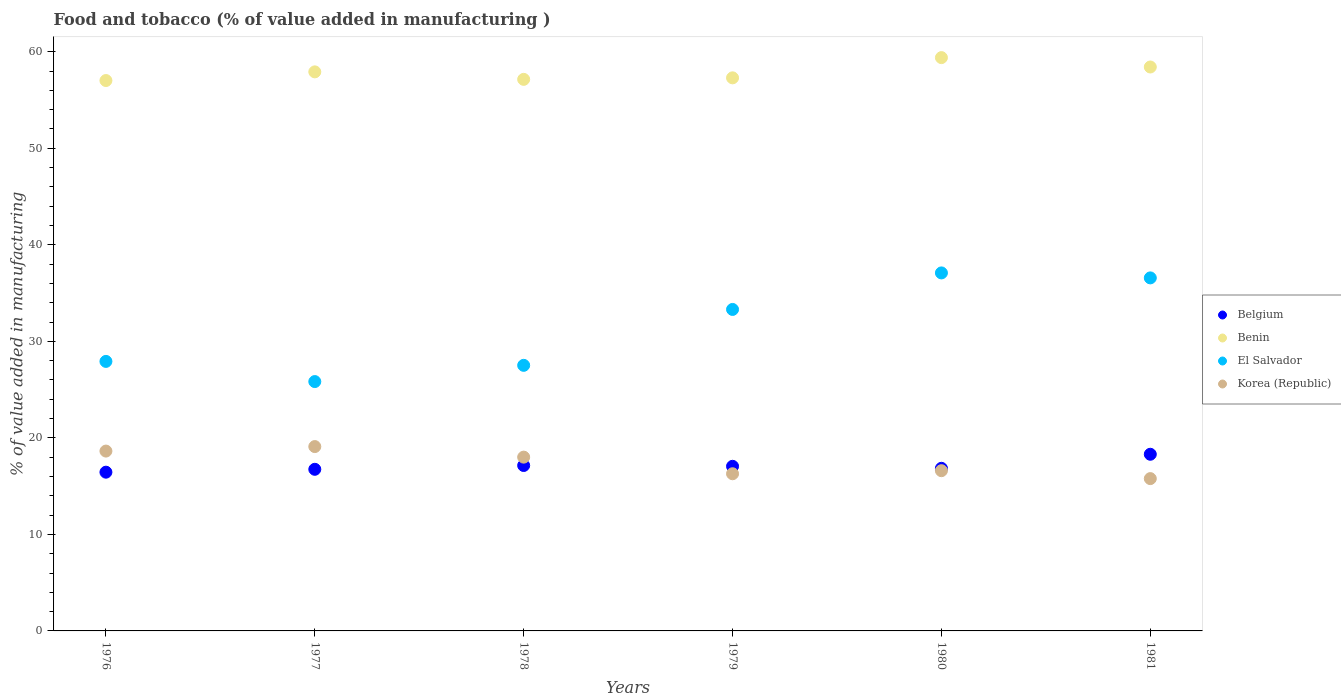How many different coloured dotlines are there?
Ensure brevity in your answer.  4. What is the value added in manufacturing food and tobacco in Belgium in 1976?
Keep it short and to the point. 16.44. Across all years, what is the maximum value added in manufacturing food and tobacco in El Salvador?
Provide a succinct answer. 37.09. Across all years, what is the minimum value added in manufacturing food and tobacco in Belgium?
Offer a terse response. 16.44. In which year was the value added in manufacturing food and tobacco in Benin minimum?
Give a very brief answer. 1976. What is the total value added in manufacturing food and tobacco in Belgium in the graph?
Offer a terse response. 102.52. What is the difference between the value added in manufacturing food and tobacco in Belgium in 1978 and that in 1979?
Your answer should be very brief. 0.08. What is the difference between the value added in manufacturing food and tobacco in Benin in 1981 and the value added in manufacturing food and tobacco in Belgium in 1978?
Ensure brevity in your answer.  41.28. What is the average value added in manufacturing food and tobacco in Benin per year?
Your answer should be very brief. 57.86. In the year 1979, what is the difference between the value added in manufacturing food and tobacco in Benin and value added in manufacturing food and tobacco in El Salvador?
Offer a terse response. 23.99. In how many years, is the value added in manufacturing food and tobacco in El Salvador greater than 14 %?
Offer a terse response. 6. What is the ratio of the value added in manufacturing food and tobacco in El Salvador in 1976 to that in 1979?
Make the answer very short. 0.84. Is the value added in manufacturing food and tobacco in Benin in 1977 less than that in 1981?
Offer a terse response. Yes. What is the difference between the highest and the second highest value added in manufacturing food and tobacco in Korea (Republic)?
Provide a short and direct response. 0.47. What is the difference between the highest and the lowest value added in manufacturing food and tobacco in Korea (Republic)?
Offer a very short reply. 3.32. In how many years, is the value added in manufacturing food and tobacco in Benin greater than the average value added in manufacturing food and tobacco in Benin taken over all years?
Make the answer very short. 3. Is the sum of the value added in manufacturing food and tobacco in Belgium in 1976 and 1977 greater than the maximum value added in manufacturing food and tobacco in Benin across all years?
Provide a short and direct response. No. Is it the case that in every year, the sum of the value added in manufacturing food and tobacco in Korea (Republic) and value added in manufacturing food and tobacco in Belgium  is greater than the value added in manufacturing food and tobacco in El Salvador?
Ensure brevity in your answer.  No. How many dotlines are there?
Offer a very short reply. 4. What is the difference between two consecutive major ticks on the Y-axis?
Your response must be concise. 10. Where does the legend appear in the graph?
Give a very brief answer. Center right. How are the legend labels stacked?
Keep it short and to the point. Vertical. What is the title of the graph?
Ensure brevity in your answer.  Food and tobacco (% of value added in manufacturing ). Does "Mexico" appear as one of the legend labels in the graph?
Offer a terse response. No. What is the label or title of the X-axis?
Your response must be concise. Years. What is the label or title of the Y-axis?
Offer a very short reply. % of value added in manufacturing. What is the % of value added in manufacturing of Belgium in 1976?
Your answer should be compact. 16.44. What is the % of value added in manufacturing in Benin in 1976?
Keep it short and to the point. 57.02. What is the % of value added in manufacturing of El Salvador in 1976?
Provide a succinct answer. 27.92. What is the % of value added in manufacturing in Korea (Republic) in 1976?
Provide a short and direct response. 18.63. What is the % of value added in manufacturing of Belgium in 1977?
Make the answer very short. 16.74. What is the % of value added in manufacturing of Benin in 1977?
Keep it short and to the point. 57.91. What is the % of value added in manufacturing of El Salvador in 1977?
Make the answer very short. 25.83. What is the % of value added in manufacturing in Korea (Republic) in 1977?
Offer a terse response. 19.1. What is the % of value added in manufacturing in Belgium in 1978?
Your response must be concise. 17.14. What is the % of value added in manufacturing of Benin in 1978?
Your response must be concise. 57.14. What is the % of value added in manufacturing in El Salvador in 1978?
Keep it short and to the point. 27.51. What is the % of value added in manufacturing of Korea (Republic) in 1978?
Your answer should be very brief. 18. What is the % of value added in manufacturing in Belgium in 1979?
Your response must be concise. 17.05. What is the % of value added in manufacturing of Benin in 1979?
Provide a succinct answer. 57.29. What is the % of value added in manufacturing in El Salvador in 1979?
Make the answer very short. 33.3. What is the % of value added in manufacturing in Korea (Republic) in 1979?
Offer a very short reply. 16.28. What is the % of value added in manufacturing in Belgium in 1980?
Offer a terse response. 16.85. What is the % of value added in manufacturing of Benin in 1980?
Give a very brief answer. 59.39. What is the % of value added in manufacturing of El Salvador in 1980?
Offer a very short reply. 37.09. What is the % of value added in manufacturing of Korea (Republic) in 1980?
Provide a succinct answer. 16.6. What is the % of value added in manufacturing in Belgium in 1981?
Offer a terse response. 18.3. What is the % of value added in manufacturing of Benin in 1981?
Offer a terse response. 58.42. What is the % of value added in manufacturing of El Salvador in 1981?
Offer a very short reply. 36.57. What is the % of value added in manufacturing of Korea (Republic) in 1981?
Provide a succinct answer. 15.78. Across all years, what is the maximum % of value added in manufacturing in Belgium?
Your answer should be very brief. 18.3. Across all years, what is the maximum % of value added in manufacturing of Benin?
Provide a succinct answer. 59.39. Across all years, what is the maximum % of value added in manufacturing of El Salvador?
Offer a very short reply. 37.09. Across all years, what is the maximum % of value added in manufacturing of Korea (Republic)?
Make the answer very short. 19.1. Across all years, what is the minimum % of value added in manufacturing of Belgium?
Give a very brief answer. 16.44. Across all years, what is the minimum % of value added in manufacturing of Benin?
Provide a short and direct response. 57.02. Across all years, what is the minimum % of value added in manufacturing in El Salvador?
Provide a short and direct response. 25.83. Across all years, what is the minimum % of value added in manufacturing of Korea (Republic)?
Your answer should be very brief. 15.78. What is the total % of value added in manufacturing in Belgium in the graph?
Make the answer very short. 102.52. What is the total % of value added in manufacturing of Benin in the graph?
Provide a succinct answer. 347.17. What is the total % of value added in manufacturing in El Salvador in the graph?
Keep it short and to the point. 188.22. What is the total % of value added in manufacturing in Korea (Republic) in the graph?
Your response must be concise. 104.39. What is the difference between the % of value added in manufacturing of Belgium in 1976 and that in 1977?
Make the answer very short. -0.3. What is the difference between the % of value added in manufacturing of Benin in 1976 and that in 1977?
Give a very brief answer. -0.9. What is the difference between the % of value added in manufacturing in El Salvador in 1976 and that in 1977?
Keep it short and to the point. 2.09. What is the difference between the % of value added in manufacturing in Korea (Republic) in 1976 and that in 1977?
Make the answer very short. -0.47. What is the difference between the % of value added in manufacturing of Belgium in 1976 and that in 1978?
Your answer should be compact. -0.69. What is the difference between the % of value added in manufacturing in Benin in 1976 and that in 1978?
Make the answer very short. -0.12. What is the difference between the % of value added in manufacturing of El Salvador in 1976 and that in 1978?
Keep it short and to the point. 0.41. What is the difference between the % of value added in manufacturing of Korea (Republic) in 1976 and that in 1978?
Offer a terse response. 0.63. What is the difference between the % of value added in manufacturing of Belgium in 1976 and that in 1979?
Offer a very short reply. -0.61. What is the difference between the % of value added in manufacturing of Benin in 1976 and that in 1979?
Provide a short and direct response. -0.28. What is the difference between the % of value added in manufacturing in El Salvador in 1976 and that in 1979?
Give a very brief answer. -5.38. What is the difference between the % of value added in manufacturing in Korea (Republic) in 1976 and that in 1979?
Your answer should be compact. 2.35. What is the difference between the % of value added in manufacturing in Belgium in 1976 and that in 1980?
Your response must be concise. -0.4. What is the difference between the % of value added in manufacturing of Benin in 1976 and that in 1980?
Make the answer very short. -2.37. What is the difference between the % of value added in manufacturing in El Salvador in 1976 and that in 1980?
Ensure brevity in your answer.  -9.17. What is the difference between the % of value added in manufacturing in Korea (Republic) in 1976 and that in 1980?
Give a very brief answer. 2.03. What is the difference between the % of value added in manufacturing in Belgium in 1976 and that in 1981?
Offer a terse response. -1.86. What is the difference between the % of value added in manufacturing of Benin in 1976 and that in 1981?
Provide a succinct answer. -1.4. What is the difference between the % of value added in manufacturing in El Salvador in 1976 and that in 1981?
Your answer should be compact. -8.65. What is the difference between the % of value added in manufacturing of Korea (Republic) in 1976 and that in 1981?
Provide a succinct answer. 2.85. What is the difference between the % of value added in manufacturing of Belgium in 1977 and that in 1978?
Offer a terse response. -0.39. What is the difference between the % of value added in manufacturing of Benin in 1977 and that in 1978?
Provide a short and direct response. 0.78. What is the difference between the % of value added in manufacturing of El Salvador in 1977 and that in 1978?
Give a very brief answer. -1.68. What is the difference between the % of value added in manufacturing of Korea (Republic) in 1977 and that in 1978?
Provide a succinct answer. 1.09. What is the difference between the % of value added in manufacturing of Belgium in 1977 and that in 1979?
Your answer should be very brief. -0.31. What is the difference between the % of value added in manufacturing in Benin in 1977 and that in 1979?
Your answer should be very brief. 0.62. What is the difference between the % of value added in manufacturing in El Salvador in 1977 and that in 1979?
Make the answer very short. -7.47. What is the difference between the % of value added in manufacturing of Korea (Republic) in 1977 and that in 1979?
Provide a short and direct response. 2.81. What is the difference between the % of value added in manufacturing of Belgium in 1977 and that in 1980?
Offer a very short reply. -0.1. What is the difference between the % of value added in manufacturing of Benin in 1977 and that in 1980?
Ensure brevity in your answer.  -1.48. What is the difference between the % of value added in manufacturing of El Salvador in 1977 and that in 1980?
Ensure brevity in your answer.  -11.26. What is the difference between the % of value added in manufacturing of Korea (Republic) in 1977 and that in 1980?
Offer a very short reply. 2.5. What is the difference between the % of value added in manufacturing of Belgium in 1977 and that in 1981?
Your response must be concise. -1.56. What is the difference between the % of value added in manufacturing of Benin in 1977 and that in 1981?
Keep it short and to the point. -0.5. What is the difference between the % of value added in manufacturing in El Salvador in 1977 and that in 1981?
Your answer should be compact. -10.74. What is the difference between the % of value added in manufacturing of Korea (Republic) in 1977 and that in 1981?
Give a very brief answer. 3.32. What is the difference between the % of value added in manufacturing of Belgium in 1978 and that in 1979?
Your answer should be compact. 0.08. What is the difference between the % of value added in manufacturing of Benin in 1978 and that in 1979?
Keep it short and to the point. -0.16. What is the difference between the % of value added in manufacturing in El Salvador in 1978 and that in 1979?
Your response must be concise. -5.79. What is the difference between the % of value added in manufacturing of Korea (Republic) in 1978 and that in 1979?
Ensure brevity in your answer.  1.72. What is the difference between the % of value added in manufacturing in Belgium in 1978 and that in 1980?
Your answer should be compact. 0.29. What is the difference between the % of value added in manufacturing of Benin in 1978 and that in 1980?
Your answer should be compact. -2.25. What is the difference between the % of value added in manufacturing of El Salvador in 1978 and that in 1980?
Your answer should be compact. -9.57. What is the difference between the % of value added in manufacturing of Korea (Republic) in 1978 and that in 1980?
Offer a very short reply. 1.4. What is the difference between the % of value added in manufacturing in Belgium in 1978 and that in 1981?
Give a very brief answer. -1.16. What is the difference between the % of value added in manufacturing in Benin in 1978 and that in 1981?
Your response must be concise. -1.28. What is the difference between the % of value added in manufacturing of El Salvador in 1978 and that in 1981?
Provide a short and direct response. -9.06. What is the difference between the % of value added in manufacturing of Korea (Republic) in 1978 and that in 1981?
Your answer should be compact. 2.22. What is the difference between the % of value added in manufacturing in Belgium in 1979 and that in 1980?
Ensure brevity in your answer.  0.21. What is the difference between the % of value added in manufacturing of Benin in 1979 and that in 1980?
Keep it short and to the point. -2.09. What is the difference between the % of value added in manufacturing in El Salvador in 1979 and that in 1980?
Give a very brief answer. -3.78. What is the difference between the % of value added in manufacturing of Korea (Republic) in 1979 and that in 1980?
Your response must be concise. -0.32. What is the difference between the % of value added in manufacturing of Belgium in 1979 and that in 1981?
Offer a terse response. -1.25. What is the difference between the % of value added in manufacturing of Benin in 1979 and that in 1981?
Provide a short and direct response. -1.12. What is the difference between the % of value added in manufacturing in El Salvador in 1979 and that in 1981?
Ensure brevity in your answer.  -3.27. What is the difference between the % of value added in manufacturing of Korea (Republic) in 1979 and that in 1981?
Give a very brief answer. 0.5. What is the difference between the % of value added in manufacturing in Belgium in 1980 and that in 1981?
Offer a very short reply. -1.45. What is the difference between the % of value added in manufacturing in Benin in 1980 and that in 1981?
Offer a terse response. 0.97. What is the difference between the % of value added in manufacturing in El Salvador in 1980 and that in 1981?
Provide a short and direct response. 0.52. What is the difference between the % of value added in manufacturing of Korea (Republic) in 1980 and that in 1981?
Give a very brief answer. 0.82. What is the difference between the % of value added in manufacturing in Belgium in 1976 and the % of value added in manufacturing in Benin in 1977?
Offer a terse response. -41.47. What is the difference between the % of value added in manufacturing in Belgium in 1976 and the % of value added in manufacturing in El Salvador in 1977?
Your answer should be very brief. -9.39. What is the difference between the % of value added in manufacturing of Belgium in 1976 and the % of value added in manufacturing of Korea (Republic) in 1977?
Give a very brief answer. -2.65. What is the difference between the % of value added in manufacturing of Benin in 1976 and the % of value added in manufacturing of El Salvador in 1977?
Offer a very short reply. 31.19. What is the difference between the % of value added in manufacturing of Benin in 1976 and the % of value added in manufacturing of Korea (Republic) in 1977?
Provide a short and direct response. 37.92. What is the difference between the % of value added in manufacturing of El Salvador in 1976 and the % of value added in manufacturing of Korea (Republic) in 1977?
Make the answer very short. 8.82. What is the difference between the % of value added in manufacturing in Belgium in 1976 and the % of value added in manufacturing in Benin in 1978?
Make the answer very short. -40.69. What is the difference between the % of value added in manufacturing of Belgium in 1976 and the % of value added in manufacturing of El Salvador in 1978?
Make the answer very short. -11.07. What is the difference between the % of value added in manufacturing of Belgium in 1976 and the % of value added in manufacturing of Korea (Republic) in 1978?
Your answer should be very brief. -1.56. What is the difference between the % of value added in manufacturing in Benin in 1976 and the % of value added in manufacturing in El Salvador in 1978?
Offer a terse response. 29.5. What is the difference between the % of value added in manufacturing in Benin in 1976 and the % of value added in manufacturing in Korea (Republic) in 1978?
Provide a short and direct response. 39.01. What is the difference between the % of value added in manufacturing of El Salvador in 1976 and the % of value added in manufacturing of Korea (Republic) in 1978?
Your answer should be very brief. 9.92. What is the difference between the % of value added in manufacturing in Belgium in 1976 and the % of value added in manufacturing in Benin in 1979?
Offer a terse response. -40.85. What is the difference between the % of value added in manufacturing in Belgium in 1976 and the % of value added in manufacturing in El Salvador in 1979?
Your response must be concise. -16.86. What is the difference between the % of value added in manufacturing of Belgium in 1976 and the % of value added in manufacturing of Korea (Republic) in 1979?
Provide a short and direct response. 0.16. What is the difference between the % of value added in manufacturing of Benin in 1976 and the % of value added in manufacturing of El Salvador in 1979?
Offer a very short reply. 23.71. What is the difference between the % of value added in manufacturing in Benin in 1976 and the % of value added in manufacturing in Korea (Republic) in 1979?
Provide a succinct answer. 40.73. What is the difference between the % of value added in manufacturing of El Salvador in 1976 and the % of value added in manufacturing of Korea (Republic) in 1979?
Your response must be concise. 11.64. What is the difference between the % of value added in manufacturing of Belgium in 1976 and the % of value added in manufacturing of Benin in 1980?
Give a very brief answer. -42.94. What is the difference between the % of value added in manufacturing of Belgium in 1976 and the % of value added in manufacturing of El Salvador in 1980?
Provide a short and direct response. -20.64. What is the difference between the % of value added in manufacturing in Belgium in 1976 and the % of value added in manufacturing in Korea (Republic) in 1980?
Your answer should be compact. -0.15. What is the difference between the % of value added in manufacturing in Benin in 1976 and the % of value added in manufacturing in El Salvador in 1980?
Provide a succinct answer. 19.93. What is the difference between the % of value added in manufacturing of Benin in 1976 and the % of value added in manufacturing of Korea (Republic) in 1980?
Your response must be concise. 40.42. What is the difference between the % of value added in manufacturing of El Salvador in 1976 and the % of value added in manufacturing of Korea (Republic) in 1980?
Keep it short and to the point. 11.32. What is the difference between the % of value added in manufacturing in Belgium in 1976 and the % of value added in manufacturing in Benin in 1981?
Make the answer very short. -41.97. What is the difference between the % of value added in manufacturing of Belgium in 1976 and the % of value added in manufacturing of El Salvador in 1981?
Ensure brevity in your answer.  -20.13. What is the difference between the % of value added in manufacturing in Belgium in 1976 and the % of value added in manufacturing in Korea (Republic) in 1981?
Your response must be concise. 0.67. What is the difference between the % of value added in manufacturing in Benin in 1976 and the % of value added in manufacturing in El Salvador in 1981?
Keep it short and to the point. 20.45. What is the difference between the % of value added in manufacturing in Benin in 1976 and the % of value added in manufacturing in Korea (Republic) in 1981?
Provide a succinct answer. 41.24. What is the difference between the % of value added in manufacturing of El Salvador in 1976 and the % of value added in manufacturing of Korea (Republic) in 1981?
Give a very brief answer. 12.14. What is the difference between the % of value added in manufacturing in Belgium in 1977 and the % of value added in manufacturing in Benin in 1978?
Offer a terse response. -40.4. What is the difference between the % of value added in manufacturing in Belgium in 1977 and the % of value added in manufacturing in El Salvador in 1978?
Provide a succinct answer. -10.77. What is the difference between the % of value added in manufacturing in Belgium in 1977 and the % of value added in manufacturing in Korea (Republic) in 1978?
Provide a short and direct response. -1.26. What is the difference between the % of value added in manufacturing in Benin in 1977 and the % of value added in manufacturing in El Salvador in 1978?
Offer a terse response. 30.4. What is the difference between the % of value added in manufacturing in Benin in 1977 and the % of value added in manufacturing in Korea (Republic) in 1978?
Provide a short and direct response. 39.91. What is the difference between the % of value added in manufacturing in El Salvador in 1977 and the % of value added in manufacturing in Korea (Republic) in 1978?
Make the answer very short. 7.83. What is the difference between the % of value added in manufacturing of Belgium in 1977 and the % of value added in manufacturing of Benin in 1979?
Keep it short and to the point. -40.55. What is the difference between the % of value added in manufacturing of Belgium in 1977 and the % of value added in manufacturing of El Salvador in 1979?
Give a very brief answer. -16.56. What is the difference between the % of value added in manufacturing of Belgium in 1977 and the % of value added in manufacturing of Korea (Republic) in 1979?
Provide a short and direct response. 0.46. What is the difference between the % of value added in manufacturing of Benin in 1977 and the % of value added in manufacturing of El Salvador in 1979?
Provide a short and direct response. 24.61. What is the difference between the % of value added in manufacturing of Benin in 1977 and the % of value added in manufacturing of Korea (Republic) in 1979?
Your response must be concise. 41.63. What is the difference between the % of value added in manufacturing of El Salvador in 1977 and the % of value added in manufacturing of Korea (Republic) in 1979?
Provide a succinct answer. 9.55. What is the difference between the % of value added in manufacturing in Belgium in 1977 and the % of value added in manufacturing in Benin in 1980?
Provide a succinct answer. -42.65. What is the difference between the % of value added in manufacturing of Belgium in 1977 and the % of value added in manufacturing of El Salvador in 1980?
Your response must be concise. -20.34. What is the difference between the % of value added in manufacturing of Belgium in 1977 and the % of value added in manufacturing of Korea (Republic) in 1980?
Make the answer very short. 0.14. What is the difference between the % of value added in manufacturing in Benin in 1977 and the % of value added in manufacturing in El Salvador in 1980?
Provide a short and direct response. 20.83. What is the difference between the % of value added in manufacturing of Benin in 1977 and the % of value added in manufacturing of Korea (Republic) in 1980?
Your response must be concise. 41.32. What is the difference between the % of value added in manufacturing in El Salvador in 1977 and the % of value added in manufacturing in Korea (Republic) in 1980?
Your answer should be very brief. 9.23. What is the difference between the % of value added in manufacturing of Belgium in 1977 and the % of value added in manufacturing of Benin in 1981?
Provide a succinct answer. -41.68. What is the difference between the % of value added in manufacturing of Belgium in 1977 and the % of value added in manufacturing of El Salvador in 1981?
Give a very brief answer. -19.83. What is the difference between the % of value added in manufacturing in Belgium in 1977 and the % of value added in manufacturing in Korea (Republic) in 1981?
Ensure brevity in your answer.  0.96. What is the difference between the % of value added in manufacturing of Benin in 1977 and the % of value added in manufacturing of El Salvador in 1981?
Make the answer very short. 21.34. What is the difference between the % of value added in manufacturing in Benin in 1977 and the % of value added in manufacturing in Korea (Republic) in 1981?
Keep it short and to the point. 42.14. What is the difference between the % of value added in manufacturing of El Salvador in 1977 and the % of value added in manufacturing of Korea (Republic) in 1981?
Your response must be concise. 10.05. What is the difference between the % of value added in manufacturing in Belgium in 1978 and the % of value added in manufacturing in Benin in 1979?
Provide a short and direct response. -40.16. What is the difference between the % of value added in manufacturing in Belgium in 1978 and the % of value added in manufacturing in El Salvador in 1979?
Give a very brief answer. -16.17. What is the difference between the % of value added in manufacturing of Belgium in 1978 and the % of value added in manufacturing of Korea (Republic) in 1979?
Make the answer very short. 0.86. What is the difference between the % of value added in manufacturing of Benin in 1978 and the % of value added in manufacturing of El Salvador in 1979?
Offer a very short reply. 23.83. What is the difference between the % of value added in manufacturing in Benin in 1978 and the % of value added in manufacturing in Korea (Republic) in 1979?
Your answer should be very brief. 40.86. What is the difference between the % of value added in manufacturing of El Salvador in 1978 and the % of value added in manufacturing of Korea (Republic) in 1979?
Provide a short and direct response. 11.23. What is the difference between the % of value added in manufacturing of Belgium in 1978 and the % of value added in manufacturing of Benin in 1980?
Offer a very short reply. -42.25. What is the difference between the % of value added in manufacturing in Belgium in 1978 and the % of value added in manufacturing in El Salvador in 1980?
Make the answer very short. -19.95. What is the difference between the % of value added in manufacturing in Belgium in 1978 and the % of value added in manufacturing in Korea (Republic) in 1980?
Ensure brevity in your answer.  0.54. What is the difference between the % of value added in manufacturing of Benin in 1978 and the % of value added in manufacturing of El Salvador in 1980?
Your answer should be very brief. 20.05. What is the difference between the % of value added in manufacturing of Benin in 1978 and the % of value added in manufacturing of Korea (Republic) in 1980?
Provide a short and direct response. 40.54. What is the difference between the % of value added in manufacturing in El Salvador in 1978 and the % of value added in manufacturing in Korea (Republic) in 1980?
Keep it short and to the point. 10.91. What is the difference between the % of value added in manufacturing in Belgium in 1978 and the % of value added in manufacturing in Benin in 1981?
Give a very brief answer. -41.28. What is the difference between the % of value added in manufacturing in Belgium in 1978 and the % of value added in manufacturing in El Salvador in 1981?
Offer a very short reply. -19.43. What is the difference between the % of value added in manufacturing of Belgium in 1978 and the % of value added in manufacturing of Korea (Republic) in 1981?
Make the answer very short. 1.36. What is the difference between the % of value added in manufacturing of Benin in 1978 and the % of value added in manufacturing of El Salvador in 1981?
Your answer should be very brief. 20.57. What is the difference between the % of value added in manufacturing in Benin in 1978 and the % of value added in manufacturing in Korea (Republic) in 1981?
Your answer should be very brief. 41.36. What is the difference between the % of value added in manufacturing in El Salvador in 1978 and the % of value added in manufacturing in Korea (Republic) in 1981?
Your answer should be compact. 11.73. What is the difference between the % of value added in manufacturing of Belgium in 1979 and the % of value added in manufacturing of Benin in 1980?
Offer a very short reply. -42.34. What is the difference between the % of value added in manufacturing in Belgium in 1979 and the % of value added in manufacturing in El Salvador in 1980?
Ensure brevity in your answer.  -20.03. What is the difference between the % of value added in manufacturing in Belgium in 1979 and the % of value added in manufacturing in Korea (Republic) in 1980?
Your response must be concise. 0.46. What is the difference between the % of value added in manufacturing in Benin in 1979 and the % of value added in manufacturing in El Salvador in 1980?
Your answer should be compact. 20.21. What is the difference between the % of value added in manufacturing in Benin in 1979 and the % of value added in manufacturing in Korea (Republic) in 1980?
Provide a succinct answer. 40.7. What is the difference between the % of value added in manufacturing of El Salvador in 1979 and the % of value added in manufacturing of Korea (Republic) in 1980?
Give a very brief answer. 16.7. What is the difference between the % of value added in manufacturing in Belgium in 1979 and the % of value added in manufacturing in Benin in 1981?
Your answer should be very brief. -41.36. What is the difference between the % of value added in manufacturing of Belgium in 1979 and the % of value added in manufacturing of El Salvador in 1981?
Ensure brevity in your answer.  -19.52. What is the difference between the % of value added in manufacturing in Belgium in 1979 and the % of value added in manufacturing in Korea (Republic) in 1981?
Your answer should be very brief. 1.27. What is the difference between the % of value added in manufacturing in Benin in 1979 and the % of value added in manufacturing in El Salvador in 1981?
Offer a very short reply. 20.72. What is the difference between the % of value added in manufacturing in Benin in 1979 and the % of value added in manufacturing in Korea (Republic) in 1981?
Make the answer very short. 41.52. What is the difference between the % of value added in manufacturing of El Salvador in 1979 and the % of value added in manufacturing of Korea (Republic) in 1981?
Provide a short and direct response. 17.52. What is the difference between the % of value added in manufacturing in Belgium in 1980 and the % of value added in manufacturing in Benin in 1981?
Your answer should be compact. -41.57. What is the difference between the % of value added in manufacturing of Belgium in 1980 and the % of value added in manufacturing of El Salvador in 1981?
Make the answer very short. -19.73. What is the difference between the % of value added in manufacturing of Belgium in 1980 and the % of value added in manufacturing of Korea (Republic) in 1981?
Your response must be concise. 1.07. What is the difference between the % of value added in manufacturing of Benin in 1980 and the % of value added in manufacturing of El Salvador in 1981?
Provide a short and direct response. 22.82. What is the difference between the % of value added in manufacturing in Benin in 1980 and the % of value added in manufacturing in Korea (Republic) in 1981?
Provide a short and direct response. 43.61. What is the difference between the % of value added in manufacturing in El Salvador in 1980 and the % of value added in manufacturing in Korea (Republic) in 1981?
Provide a short and direct response. 21.31. What is the average % of value added in manufacturing of Belgium per year?
Offer a terse response. 17.09. What is the average % of value added in manufacturing of Benin per year?
Give a very brief answer. 57.86. What is the average % of value added in manufacturing in El Salvador per year?
Ensure brevity in your answer.  31.37. What is the average % of value added in manufacturing of Korea (Republic) per year?
Ensure brevity in your answer.  17.4. In the year 1976, what is the difference between the % of value added in manufacturing of Belgium and % of value added in manufacturing of Benin?
Your answer should be compact. -40.57. In the year 1976, what is the difference between the % of value added in manufacturing of Belgium and % of value added in manufacturing of El Salvador?
Make the answer very short. -11.47. In the year 1976, what is the difference between the % of value added in manufacturing in Belgium and % of value added in manufacturing in Korea (Republic)?
Offer a terse response. -2.19. In the year 1976, what is the difference between the % of value added in manufacturing in Benin and % of value added in manufacturing in El Salvador?
Provide a short and direct response. 29.1. In the year 1976, what is the difference between the % of value added in manufacturing of Benin and % of value added in manufacturing of Korea (Republic)?
Your answer should be very brief. 38.39. In the year 1976, what is the difference between the % of value added in manufacturing in El Salvador and % of value added in manufacturing in Korea (Republic)?
Ensure brevity in your answer.  9.29. In the year 1977, what is the difference between the % of value added in manufacturing in Belgium and % of value added in manufacturing in Benin?
Your response must be concise. -41.17. In the year 1977, what is the difference between the % of value added in manufacturing of Belgium and % of value added in manufacturing of El Salvador?
Your response must be concise. -9.09. In the year 1977, what is the difference between the % of value added in manufacturing of Belgium and % of value added in manufacturing of Korea (Republic)?
Make the answer very short. -2.35. In the year 1977, what is the difference between the % of value added in manufacturing of Benin and % of value added in manufacturing of El Salvador?
Your answer should be very brief. 32.08. In the year 1977, what is the difference between the % of value added in manufacturing in Benin and % of value added in manufacturing in Korea (Republic)?
Your response must be concise. 38.82. In the year 1977, what is the difference between the % of value added in manufacturing of El Salvador and % of value added in manufacturing of Korea (Republic)?
Make the answer very short. 6.73. In the year 1978, what is the difference between the % of value added in manufacturing of Belgium and % of value added in manufacturing of Benin?
Give a very brief answer. -40. In the year 1978, what is the difference between the % of value added in manufacturing of Belgium and % of value added in manufacturing of El Salvador?
Offer a terse response. -10.38. In the year 1978, what is the difference between the % of value added in manufacturing of Belgium and % of value added in manufacturing of Korea (Republic)?
Offer a terse response. -0.87. In the year 1978, what is the difference between the % of value added in manufacturing of Benin and % of value added in manufacturing of El Salvador?
Provide a succinct answer. 29.63. In the year 1978, what is the difference between the % of value added in manufacturing in Benin and % of value added in manufacturing in Korea (Republic)?
Keep it short and to the point. 39.13. In the year 1978, what is the difference between the % of value added in manufacturing of El Salvador and % of value added in manufacturing of Korea (Republic)?
Provide a succinct answer. 9.51. In the year 1979, what is the difference between the % of value added in manufacturing of Belgium and % of value added in manufacturing of Benin?
Make the answer very short. -40.24. In the year 1979, what is the difference between the % of value added in manufacturing of Belgium and % of value added in manufacturing of El Salvador?
Your answer should be compact. -16.25. In the year 1979, what is the difference between the % of value added in manufacturing of Belgium and % of value added in manufacturing of Korea (Republic)?
Your response must be concise. 0.77. In the year 1979, what is the difference between the % of value added in manufacturing in Benin and % of value added in manufacturing in El Salvador?
Your response must be concise. 23.99. In the year 1979, what is the difference between the % of value added in manufacturing in Benin and % of value added in manufacturing in Korea (Republic)?
Your answer should be compact. 41.01. In the year 1979, what is the difference between the % of value added in manufacturing of El Salvador and % of value added in manufacturing of Korea (Republic)?
Give a very brief answer. 17.02. In the year 1980, what is the difference between the % of value added in manufacturing in Belgium and % of value added in manufacturing in Benin?
Provide a succinct answer. -42.54. In the year 1980, what is the difference between the % of value added in manufacturing in Belgium and % of value added in manufacturing in El Salvador?
Offer a terse response. -20.24. In the year 1980, what is the difference between the % of value added in manufacturing in Belgium and % of value added in manufacturing in Korea (Republic)?
Your answer should be very brief. 0.25. In the year 1980, what is the difference between the % of value added in manufacturing in Benin and % of value added in manufacturing in El Salvador?
Make the answer very short. 22.3. In the year 1980, what is the difference between the % of value added in manufacturing in Benin and % of value added in manufacturing in Korea (Republic)?
Provide a short and direct response. 42.79. In the year 1980, what is the difference between the % of value added in manufacturing in El Salvador and % of value added in manufacturing in Korea (Republic)?
Keep it short and to the point. 20.49. In the year 1981, what is the difference between the % of value added in manufacturing in Belgium and % of value added in manufacturing in Benin?
Your response must be concise. -40.12. In the year 1981, what is the difference between the % of value added in manufacturing of Belgium and % of value added in manufacturing of El Salvador?
Your answer should be very brief. -18.27. In the year 1981, what is the difference between the % of value added in manufacturing in Belgium and % of value added in manufacturing in Korea (Republic)?
Provide a short and direct response. 2.52. In the year 1981, what is the difference between the % of value added in manufacturing of Benin and % of value added in manufacturing of El Salvador?
Ensure brevity in your answer.  21.85. In the year 1981, what is the difference between the % of value added in manufacturing in Benin and % of value added in manufacturing in Korea (Republic)?
Your response must be concise. 42.64. In the year 1981, what is the difference between the % of value added in manufacturing in El Salvador and % of value added in manufacturing in Korea (Republic)?
Your answer should be compact. 20.79. What is the ratio of the % of value added in manufacturing in Belgium in 1976 to that in 1977?
Your answer should be compact. 0.98. What is the ratio of the % of value added in manufacturing in Benin in 1976 to that in 1977?
Ensure brevity in your answer.  0.98. What is the ratio of the % of value added in manufacturing of El Salvador in 1976 to that in 1977?
Keep it short and to the point. 1.08. What is the ratio of the % of value added in manufacturing of Korea (Republic) in 1976 to that in 1977?
Your response must be concise. 0.98. What is the ratio of the % of value added in manufacturing in Belgium in 1976 to that in 1978?
Your response must be concise. 0.96. What is the ratio of the % of value added in manufacturing in Benin in 1976 to that in 1978?
Offer a terse response. 1. What is the ratio of the % of value added in manufacturing in El Salvador in 1976 to that in 1978?
Your response must be concise. 1.01. What is the ratio of the % of value added in manufacturing in Korea (Republic) in 1976 to that in 1978?
Give a very brief answer. 1.03. What is the ratio of the % of value added in manufacturing in Belgium in 1976 to that in 1979?
Offer a terse response. 0.96. What is the ratio of the % of value added in manufacturing of Benin in 1976 to that in 1979?
Your response must be concise. 1. What is the ratio of the % of value added in manufacturing of El Salvador in 1976 to that in 1979?
Offer a terse response. 0.84. What is the ratio of the % of value added in manufacturing of Korea (Republic) in 1976 to that in 1979?
Give a very brief answer. 1.14. What is the ratio of the % of value added in manufacturing in Belgium in 1976 to that in 1980?
Your answer should be compact. 0.98. What is the ratio of the % of value added in manufacturing of El Salvador in 1976 to that in 1980?
Offer a very short reply. 0.75. What is the ratio of the % of value added in manufacturing of Korea (Republic) in 1976 to that in 1980?
Your response must be concise. 1.12. What is the ratio of the % of value added in manufacturing of Belgium in 1976 to that in 1981?
Make the answer very short. 0.9. What is the ratio of the % of value added in manufacturing of Benin in 1976 to that in 1981?
Give a very brief answer. 0.98. What is the ratio of the % of value added in manufacturing of El Salvador in 1976 to that in 1981?
Ensure brevity in your answer.  0.76. What is the ratio of the % of value added in manufacturing of Korea (Republic) in 1976 to that in 1981?
Keep it short and to the point. 1.18. What is the ratio of the % of value added in manufacturing in Benin in 1977 to that in 1978?
Provide a succinct answer. 1.01. What is the ratio of the % of value added in manufacturing of El Salvador in 1977 to that in 1978?
Provide a succinct answer. 0.94. What is the ratio of the % of value added in manufacturing of Korea (Republic) in 1977 to that in 1978?
Provide a short and direct response. 1.06. What is the ratio of the % of value added in manufacturing of Belgium in 1977 to that in 1979?
Offer a very short reply. 0.98. What is the ratio of the % of value added in manufacturing in Benin in 1977 to that in 1979?
Offer a very short reply. 1.01. What is the ratio of the % of value added in manufacturing of El Salvador in 1977 to that in 1979?
Provide a short and direct response. 0.78. What is the ratio of the % of value added in manufacturing of Korea (Republic) in 1977 to that in 1979?
Offer a very short reply. 1.17. What is the ratio of the % of value added in manufacturing of Belgium in 1977 to that in 1980?
Your answer should be compact. 0.99. What is the ratio of the % of value added in manufacturing of Benin in 1977 to that in 1980?
Make the answer very short. 0.98. What is the ratio of the % of value added in manufacturing in El Salvador in 1977 to that in 1980?
Provide a succinct answer. 0.7. What is the ratio of the % of value added in manufacturing in Korea (Republic) in 1977 to that in 1980?
Your answer should be compact. 1.15. What is the ratio of the % of value added in manufacturing in Belgium in 1977 to that in 1981?
Offer a terse response. 0.91. What is the ratio of the % of value added in manufacturing in El Salvador in 1977 to that in 1981?
Offer a very short reply. 0.71. What is the ratio of the % of value added in manufacturing in Korea (Republic) in 1977 to that in 1981?
Offer a terse response. 1.21. What is the ratio of the % of value added in manufacturing of Benin in 1978 to that in 1979?
Your answer should be very brief. 1. What is the ratio of the % of value added in manufacturing in El Salvador in 1978 to that in 1979?
Offer a very short reply. 0.83. What is the ratio of the % of value added in manufacturing of Korea (Republic) in 1978 to that in 1979?
Keep it short and to the point. 1.11. What is the ratio of the % of value added in manufacturing of Belgium in 1978 to that in 1980?
Provide a short and direct response. 1.02. What is the ratio of the % of value added in manufacturing in Benin in 1978 to that in 1980?
Offer a very short reply. 0.96. What is the ratio of the % of value added in manufacturing in El Salvador in 1978 to that in 1980?
Make the answer very short. 0.74. What is the ratio of the % of value added in manufacturing of Korea (Republic) in 1978 to that in 1980?
Offer a terse response. 1.08. What is the ratio of the % of value added in manufacturing in Belgium in 1978 to that in 1981?
Offer a terse response. 0.94. What is the ratio of the % of value added in manufacturing of Benin in 1978 to that in 1981?
Give a very brief answer. 0.98. What is the ratio of the % of value added in manufacturing of El Salvador in 1978 to that in 1981?
Ensure brevity in your answer.  0.75. What is the ratio of the % of value added in manufacturing of Korea (Republic) in 1978 to that in 1981?
Provide a short and direct response. 1.14. What is the ratio of the % of value added in manufacturing of Belgium in 1979 to that in 1980?
Make the answer very short. 1.01. What is the ratio of the % of value added in manufacturing of Benin in 1979 to that in 1980?
Make the answer very short. 0.96. What is the ratio of the % of value added in manufacturing in El Salvador in 1979 to that in 1980?
Ensure brevity in your answer.  0.9. What is the ratio of the % of value added in manufacturing in Korea (Republic) in 1979 to that in 1980?
Keep it short and to the point. 0.98. What is the ratio of the % of value added in manufacturing of Belgium in 1979 to that in 1981?
Provide a succinct answer. 0.93. What is the ratio of the % of value added in manufacturing of Benin in 1979 to that in 1981?
Your answer should be very brief. 0.98. What is the ratio of the % of value added in manufacturing of El Salvador in 1979 to that in 1981?
Your answer should be very brief. 0.91. What is the ratio of the % of value added in manufacturing of Korea (Republic) in 1979 to that in 1981?
Your response must be concise. 1.03. What is the ratio of the % of value added in manufacturing in Belgium in 1980 to that in 1981?
Offer a very short reply. 0.92. What is the ratio of the % of value added in manufacturing of Benin in 1980 to that in 1981?
Your answer should be very brief. 1.02. What is the ratio of the % of value added in manufacturing of El Salvador in 1980 to that in 1981?
Your answer should be very brief. 1.01. What is the ratio of the % of value added in manufacturing of Korea (Republic) in 1980 to that in 1981?
Ensure brevity in your answer.  1.05. What is the difference between the highest and the second highest % of value added in manufacturing of Belgium?
Offer a terse response. 1.16. What is the difference between the highest and the second highest % of value added in manufacturing in Benin?
Offer a terse response. 0.97. What is the difference between the highest and the second highest % of value added in manufacturing of El Salvador?
Provide a succinct answer. 0.52. What is the difference between the highest and the second highest % of value added in manufacturing in Korea (Republic)?
Offer a very short reply. 0.47. What is the difference between the highest and the lowest % of value added in manufacturing in Belgium?
Ensure brevity in your answer.  1.86. What is the difference between the highest and the lowest % of value added in manufacturing in Benin?
Offer a terse response. 2.37. What is the difference between the highest and the lowest % of value added in manufacturing of El Salvador?
Your response must be concise. 11.26. What is the difference between the highest and the lowest % of value added in manufacturing in Korea (Republic)?
Your response must be concise. 3.32. 